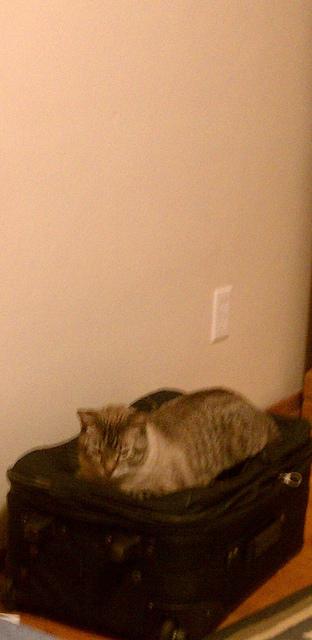Is this cat about to go to work at the post office?
Short answer required. No. Why is this photograph funny?
Keep it brief. Cat. What keeps the pockets closed?
Quick response, please. Cat. What is the cat sitting on?
Be succinct. Suitcase. How many electrical outlets can you see?
Give a very brief answer. 1. What color is the wall in the background?
Quick response, please. White. What color are the walls?
Quick response, please. White. Where is the cat sleeping?
Be succinct. Suitcase. Who was sleeping here?
Give a very brief answer. Cat. Is the wall more than one color?
Be succinct. No. 